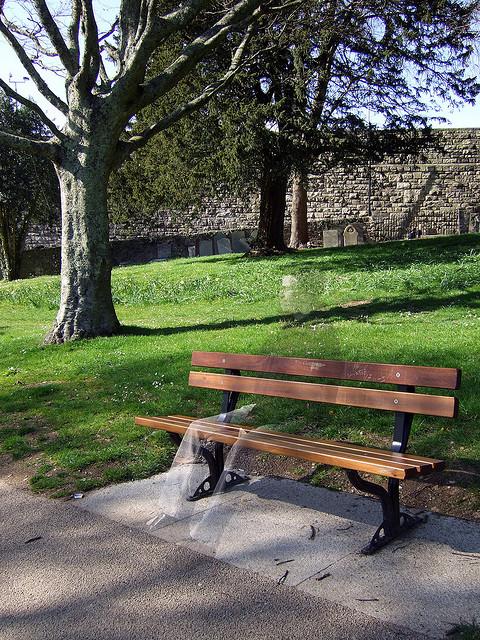What is on the bench?
Be succinct. Ghost. Is that a stone building?
Keep it brief. Yes. What is the bench made of?
Short answer required. Wood. Is that a ghost on the bench?
Quick response, please. Yes. 